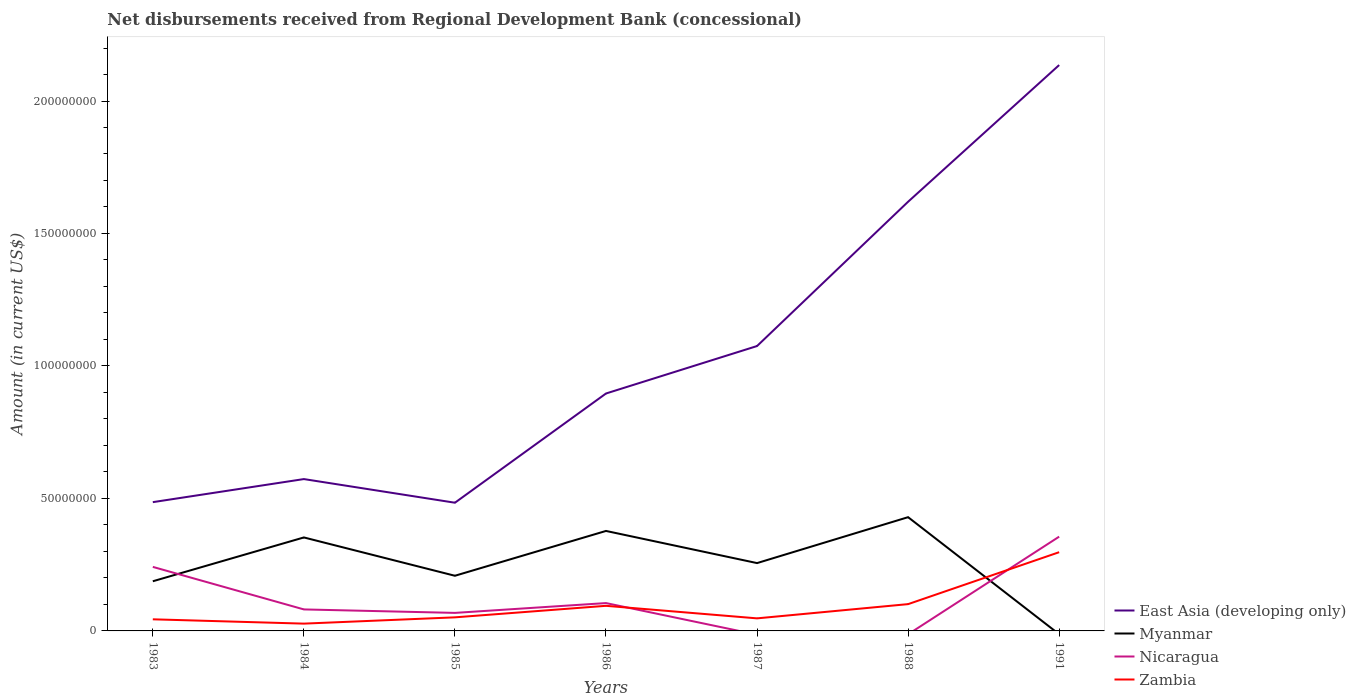How many different coloured lines are there?
Offer a very short reply. 4. Across all years, what is the maximum amount of disbursements received from Regional Development Bank in East Asia (developing only)?
Make the answer very short. 4.84e+07. What is the total amount of disbursements received from Regional Development Bank in Myanmar in the graph?
Provide a short and direct response. -1.65e+07. What is the difference between the highest and the second highest amount of disbursements received from Regional Development Bank in Zambia?
Offer a very short reply. 2.70e+07. Is the amount of disbursements received from Regional Development Bank in East Asia (developing only) strictly greater than the amount of disbursements received from Regional Development Bank in Myanmar over the years?
Your answer should be very brief. No. How many lines are there?
Provide a succinct answer. 4. How are the legend labels stacked?
Ensure brevity in your answer.  Vertical. What is the title of the graph?
Provide a succinct answer. Net disbursements received from Regional Development Bank (concessional). What is the label or title of the X-axis?
Offer a terse response. Years. What is the label or title of the Y-axis?
Your response must be concise. Amount (in current US$). What is the Amount (in current US$) in East Asia (developing only) in 1983?
Keep it short and to the point. 4.86e+07. What is the Amount (in current US$) in Myanmar in 1983?
Your response must be concise. 1.87e+07. What is the Amount (in current US$) of Nicaragua in 1983?
Offer a terse response. 2.42e+07. What is the Amount (in current US$) of Zambia in 1983?
Provide a succinct answer. 4.38e+06. What is the Amount (in current US$) in East Asia (developing only) in 1984?
Your answer should be very brief. 5.73e+07. What is the Amount (in current US$) in Myanmar in 1984?
Your answer should be compact. 3.53e+07. What is the Amount (in current US$) of Nicaragua in 1984?
Give a very brief answer. 8.12e+06. What is the Amount (in current US$) of Zambia in 1984?
Make the answer very short. 2.76e+06. What is the Amount (in current US$) in East Asia (developing only) in 1985?
Provide a short and direct response. 4.84e+07. What is the Amount (in current US$) of Myanmar in 1985?
Your answer should be compact. 2.08e+07. What is the Amount (in current US$) in Nicaragua in 1985?
Keep it short and to the point. 6.80e+06. What is the Amount (in current US$) of Zambia in 1985?
Ensure brevity in your answer.  5.12e+06. What is the Amount (in current US$) of East Asia (developing only) in 1986?
Ensure brevity in your answer.  8.96e+07. What is the Amount (in current US$) of Myanmar in 1986?
Provide a succinct answer. 3.77e+07. What is the Amount (in current US$) in Nicaragua in 1986?
Make the answer very short. 1.05e+07. What is the Amount (in current US$) of Zambia in 1986?
Provide a short and direct response. 9.48e+06. What is the Amount (in current US$) of East Asia (developing only) in 1987?
Your answer should be very brief. 1.08e+08. What is the Amount (in current US$) in Myanmar in 1987?
Make the answer very short. 2.56e+07. What is the Amount (in current US$) of Nicaragua in 1987?
Provide a succinct answer. 0. What is the Amount (in current US$) of Zambia in 1987?
Your answer should be very brief. 4.74e+06. What is the Amount (in current US$) of East Asia (developing only) in 1988?
Offer a terse response. 1.62e+08. What is the Amount (in current US$) of Myanmar in 1988?
Offer a terse response. 4.29e+07. What is the Amount (in current US$) of Zambia in 1988?
Provide a short and direct response. 1.01e+07. What is the Amount (in current US$) of East Asia (developing only) in 1991?
Ensure brevity in your answer.  2.14e+08. What is the Amount (in current US$) of Myanmar in 1991?
Your response must be concise. 0. What is the Amount (in current US$) of Nicaragua in 1991?
Your response must be concise. 3.56e+07. What is the Amount (in current US$) in Zambia in 1991?
Your response must be concise. 2.97e+07. Across all years, what is the maximum Amount (in current US$) in East Asia (developing only)?
Give a very brief answer. 2.14e+08. Across all years, what is the maximum Amount (in current US$) in Myanmar?
Make the answer very short. 4.29e+07. Across all years, what is the maximum Amount (in current US$) in Nicaragua?
Provide a short and direct response. 3.56e+07. Across all years, what is the maximum Amount (in current US$) of Zambia?
Offer a terse response. 2.97e+07. Across all years, what is the minimum Amount (in current US$) of East Asia (developing only)?
Your answer should be very brief. 4.84e+07. Across all years, what is the minimum Amount (in current US$) of Myanmar?
Give a very brief answer. 0. Across all years, what is the minimum Amount (in current US$) in Zambia?
Offer a very short reply. 2.76e+06. What is the total Amount (in current US$) in East Asia (developing only) in the graph?
Offer a very short reply. 7.27e+08. What is the total Amount (in current US$) of Myanmar in the graph?
Offer a terse response. 1.81e+08. What is the total Amount (in current US$) in Nicaragua in the graph?
Keep it short and to the point. 8.52e+07. What is the total Amount (in current US$) of Zambia in the graph?
Give a very brief answer. 6.63e+07. What is the difference between the Amount (in current US$) in East Asia (developing only) in 1983 and that in 1984?
Give a very brief answer. -8.71e+06. What is the difference between the Amount (in current US$) in Myanmar in 1983 and that in 1984?
Your answer should be very brief. -1.65e+07. What is the difference between the Amount (in current US$) in Nicaragua in 1983 and that in 1984?
Offer a terse response. 1.61e+07. What is the difference between the Amount (in current US$) of Zambia in 1983 and that in 1984?
Your answer should be very brief. 1.62e+06. What is the difference between the Amount (in current US$) in East Asia (developing only) in 1983 and that in 1985?
Offer a very short reply. 2.18e+05. What is the difference between the Amount (in current US$) in Myanmar in 1983 and that in 1985?
Your answer should be very brief. -2.08e+06. What is the difference between the Amount (in current US$) of Nicaragua in 1983 and that in 1985?
Make the answer very short. 1.74e+07. What is the difference between the Amount (in current US$) in Zambia in 1983 and that in 1985?
Offer a terse response. -7.45e+05. What is the difference between the Amount (in current US$) of East Asia (developing only) in 1983 and that in 1986?
Your answer should be compact. -4.10e+07. What is the difference between the Amount (in current US$) in Myanmar in 1983 and that in 1986?
Give a very brief answer. -1.90e+07. What is the difference between the Amount (in current US$) of Nicaragua in 1983 and that in 1986?
Provide a succinct answer. 1.37e+07. What is the difference between the Amount (in current US$) of Zambia in 1983 and that in 1986?
Provide a succinct answer. -5.10e+06. What is the difference between the Amount (in current US$) in East Asia (developing only) in 1983 and that in 1987?
Your response must be concise. -5.89e+07. What is the difference between the Amount (in current US$) in Myanmar in 1983 and that in 1987?
Provide a succinct answer. -6.86e+06. What is the difference between the Amount (in current US$) of Zambia in 1983 and that in 1987?
Offer a very short reply. -3.61e+05. What is the difference between the Amount (in current US$) of East Asia (developing only) in 1983 and that in 1988?
Offer a terse response. -1.13e+08. What is the difference between the Amount (in current US$) of Myanmar in 1983 and that in 1988?
Offer a terse response. -2.42e+07. What is the difference between the Amount (in current US$) of Zambia in 1983 and that in 1988?
Keep it short and to the point. -5.73e+06. What is the difference between the Amount (in current US$) of East Asia (developing only) in 1983 and that in 1991?
Provide a short and direct response. -1.65e+08. What is the difference between the Amount (in current US$) of Nicaragua in 1983 and that in 1991?
Your answer should be very brief. -1.14e+07. What is the difference between the Amount (in current US$) in Zambia in 1983 and that in 1991?
Give a very brief answer. -2.53e+07. What is the difference between the Amount (in current US$) in East Asia (developing only) in 1984 and that in 1985?
Offer a terse response. 8.92e+06. What is the difference between the Amount (in current US$) in Myanmar in 1984 and that in 1985?
Give a very brief answer. 1.45e+07. What is the difference between the Amount (in current US$) in Nicaragua in 1984 and that in 1985?
Provide a succinct answer. 1.31e+06. What is the difference between the Amount (in current US$) of Zambia in 1984 and that in 1985?
Ensure brevity in your answer.  -2.37e+06. What is the difference between the Amount (in current US$) in East Asia (developing only) in 1984 and that in 1986?
Provide a short and direct response. -3.23e+07. What is the difference between the Amount (in current US$) of Myanmar in 1984 and that in 1986?
Keep it short and to the point. -2.45e+06. What is the difference between the Amount (in current US$) of Nicaragua in 1984 and that in 1986?
Provide a short and direct response. -2.39e+06. What is the difference between the Amount (in current US$) of Zambia in 1984 and that in 1986?
Provide a succinct answer. -6.72e+06. What is the difference between the Amount (in current US$) of East Asia (developing only) in 1984 and that in 1987?
Give a very brief answer. -5.02e+07. What is the difference between the Amount (in current US$) of Myanmar in 1984 and that in 1987?
Your answer should be very brief. 9.68e+06. What is the difference between the Amount (in current US$) in Zambia in 1984 and that in 1987?
Provide a succinct answer. -1.98e+06. What is the difference between the Amount (in current US$) in East Asia (developing only) in 1984 and that in 1988?
Provide a short and direct response. -1.05e+08. What is the difference between the Amount (in current US$) of Myanmar in 1984 and that in 1988?
Your response must be concise. -7.65e+06. What is the difference between the Amount (in current US$) of Zambia in 1984 and that in 1988?
Keep it short and to the point. -7.36e+06. What is the difference between the Amount (in current US$) in East Asia (developing only) in 1984 and that in 1991?
Offer a very short reply. -1.56e+08. What is the difference between the Amount (in current US$) in Nicaragua in 1984 and that in 1991?
Provide a succinct answer. -2.75e+07. What is the difference between the Amount (in current US$) in Zambia in 1984 and that in 1991?
Provide a succinct answer. -2.70e+07. What is the difference between the Amount (in current US$) of East Asia (developing only) in 1985 and that in 1986?
Offer a very short reply. -4.12e+07. What is the difference between the Amount (in current US$) in Myanmar in 1985 and that in 1986?
Make the answer very short. -1.69e+07. What is the difference between the Amount (in current US$) of Nicaragua in 1985 and that in 1986?
Your answer should be compact. -3.71e+06. What is the difference between the Amount (in current US$) of Zambia in 1985 and that in 1986?
Provide a succinct answer. -4.35e+06. What is the difference between the Amount (in current US$) of East Asia (developing only) in 1985 and that in 1987?
Make the answer very short. -5.91e+07. What is the difference between the Amount (in current US$) of Myanmar in 1985 and that in 1987?
Your response must be concise. -4.78e+06. What is the difference between the Amount (in current US$) in Zambia in 1985 and that in 1987?
Make the answer very short. 3.84e+05. What is the difference between the Amount (in current US$) of East Asia (developing only) in 1985 and that in 1988?
Offer a very short reply. -1.14e+08. What is the difference between the Amount (in current US$) of Myanmar in 1985 and that in 1988?
Make the answer very short. -2.21e+07. What is the difference between the Amount (in current US$) in Zambia in 1985 and that in 1988?
Make the answer very short. -4.99e+06. What is the difference between the Amount (in current US$) in East Asia (developing only) in 1985 and that in 1991?
Offer a very short reply. -1.65e+08. What is the difference between the Amount (in current US$) of Nicaragua in 1985 and that in 1991?
Your answer should be compact. -2.88e+07. What is the difference between the Amount (in current US$) in Zambia in 1985 and that in 1991?
Provide a short and direct response. -2.46e+07. What is the difference between the Amount (in current US$) of East Asia (developing only) in 1986 and that in 1987?
Offer a very short reply. -1.79e+07. What is the difference between the Amount (in current US$) in Myanmar in 1986 and that in 1987?
Make the answer very short. 1.21e+07. What is the difference between the Amount (in current US$) in Zambia in 1986 and that in 1987?
Give a very brief answer. 4.74e+06. What is the difference between the Amount (in current US$) of East Asia (developing only) in 1986 and that in 1988?
Your answer should be compact. -7.24e+07. What is the difference between the Amount (in current US$) in Myanmar in 1986 and that in 1988?
Provide a short and direct response. -5.20e+06. What is the difference between the Amount (in current US$) in Zambia in 1986 and that in 1988?
Your response must be concise. -6.37e+05. What is the difference between the Amount (in current US$) of East Asia (developing only) in 1986 and that in 1991?
Ensure brevity in your answer.  -1.24e+08. What is the difference between the Amount (in current US$) of Nicaragua in 1986 and that in 1991?
Provide a short and direct response. -2.51e+07. What is the difference between the Amount (in current US$) in Zambia in 1986 and that in 1991?
Offer a terse response. -2.02e+07. What is the difference between the Amount (in current US$) in East Asia (developing only) in 1987 and that in 1988?
Offer a very short reply. -5.45e+07. What is the difference between the Amount (in current US$) of Myanmar in 1987 and that in 1988?
Make the answer very short. -1.73e+07. What is the difference between the Amount (in current US$) of Zambia in 1987 and that in 1988?
Offer a very short reply. -5.37e+06. What is the difference between the Amount (in current US$) in East Asia (developing only) in 1987 and that in 1991?
Make the answer very short. -1.06e+08. What is the difference between the Amount (in current US$) of Zambia in 1987 and that in 1991?
Your answer should be very brief. -2.50e+07. What is the difference between the Amount (in current US$) of East Asia (developing only) in 1988 and that in 1991?
Your answer should be compact. -5.16e+07. What is the difference between the Amount (in current US$) in Zambia in 1988 and that in 1991?
Keep it short and to the point. -1.96e+07. What is the difference between the Amount (in current US$) of East Asia (developing only) in 1983 and the Amount (in current US$) of Myanmar in 1984?
Your response must be concise. 1.33e+07. What is the difference between the Amount (in current US$) of East Asia (developing only) in 1983 and the Amount (in current US$) of Nicaragua in 1984?
Your response must be concise. 4.05e+07. What is the difference between the Amount (in current US$) in East Asia (developing only) in 1983 and the Amount (in current US$) in Zambia in 1984?
Make the answer very short. 4.58e+07. What is the difference between the Amount (in current US$) in Myanmar in 1983 and the Amount (in current US$) in Nicaragua in 1984?
Give a very brief answer. 1.06e+07. What is the difference between the Amount (in current US$) in Myanmar in 1983 and the Amount (in current US$) in Zambia in 1984?
Provide a succinct answer. 1.60e+07. What is the difference between the Amount (in current US$) in Nicaragua in 1983 and the Amount (in current US$) in Zambia in 1984?
Make the answer very short. 2.14e+07. What is the difference between the Amount (in current US$) in East Asia (developing only) in 1983 and the Amount (in current US$) in Myanmar in 1985?
Provide a succinct answer. 2.78e+07. What is the difference between the Amount (in current US$) of East Asia (developing only) in 1983 and the Amount (in current US$) of Nicaragua in 1985?
Give a very brief answer. 4.18e+07. What is the difference between the Amount (in current US$) of East Asia (developing only) in 1983 and the Amount (in current US$) of Zambia in 1985?
Your answer should be compact. 4.35e+07. What is the difference between the Amount (in current US$) of Myanmar in 1983 and the Amount (in current US$) of Nicaragua in 1985?
Keep it short and to the point. 1.19e+07. What is the difference between the Amount (in current US$) in Myanmar in 1983 and the Amount (in current US$) in Zambia in 1985?
Your response must be concise. 1.36e+07. What is the difference between the Amount (in current US$) of Nicaragua in 1983 and the Amount (in current US$) of Zambia in 1985?
Provide a succinct answer. 1.90e+07. What is the difference between the Amount (in current US$) in East Asia (developing only) in 1983 and the Amount (in current US$) in Myanmar in 1986?
Your response must be concise. 1.09e+07. What is the difference between the Amount (in current US$) in East Asia (developing only) in 1983 and the Amount (in current US$) in Nicaragua in 1986?
Provide a succinct answer. 3.81e+07. What is the difference between the Amount (in current US$) of East Asia (developing only) in 1983 and the Amount (in current US$) of Zambia in 1986?
Provide a short and direct response. 3.91e+07. What is the difference between the Amount (in current US$) of Myanmar in 1983 and the Amount (in current US$) of Nicaragua in 1986?
Your answer should be compact. 8.23e+06. What is the difference between the Amount (in current US$) in Myanmar in 1983 and the Amount (in current US$) in Zambia in 1986?
Provide a short and direct response. 9.26e+06. What is the difference between the Amount (in current US$) in Nicaragua in 1983 and the Amount (in current US$) in Zambia in 1986?
Give a very brief answer. 1.47e+07. What is the difference between the Amount (in current US$) of East Asia (developing only) in 1983 and the Amount (in current US$) of Myanmar in 1987?
Make the answer very short. 2.30e+07. What is the difference between the Amount (in current US$) of East Asia (developing only) in 1983 and the Amount (in current US$) of Zambia in 1987?
Offer a terse response. 4.39e+07. What is the difference between the Amount (in current US$) in Myanmar in 1983 and the Amount (in current US$) in Zambia in 1987?
Offer a terse response. 1.40e+07. What is the difference between the Amount (in current US$) in Nicaragua in 1983 and the Amount (in current US$) in Zambia in 1987?
Offer a terse response. 1.94e+07. What is the difference between the Amount (in current US$) in East Asia (developing only) in 1983 and the Amount (in current US$) in Myanmar in 1988?
Your answer should be very brief. 5.67e+06. What is the difference between the Amount (in current US$) of East Asia (developing only) in 1983 and the Amount (in current US$) of Zambia in 1988?
Provide a short and direct response. 3.85e+07. What is the difference between the Amount (in current US$) of Myanmar in 1983 and the Amount (in current US$) of Zambia in 1988?
Your answer should be very brief. 8.63e+06. What is the difference between the Amount (in current US$) in Nicaragua in 1983 and the Amount (in current US$) in Zambia in 1988?
Offer a terse response. 1.41e+07. What is the difference between the Amount (in current US$) of East Asia (developing only) in 1983 and the Amount (in current US$) of Nicaragua in 1991?
Keep it short and to the point. 1.30e+07. What is the difference between the Amount (in current US$) in East Asia (developing only) in 1983 and the Amount (in current US$) in Zambia in 1991?
Ensure brevity in your answer.  1.89e+07. What is the difference between the Amount (in current US$) in Myanmar in 1983 and the Amount (in current US$) in Nicaragua in 1991?
Make the answer very short. -1.68e+07. What is the difference between the Amount (in current US$) of Myanmar in 1983 and the Amount (in current US$) of Zambia in 1991?
Offer a very short reply. -1.10e+07. What is the difference between the Amount (in current US$) of Nicaragua in 1983 and the Amount (in current US$) of Zambia in 1991?
Your answer should be compact. -5.54e+06. What is the difference between the Amount (in current US$) of East Asia (developing only) in 1984 and the Amount (in current US$) of Myanmar in 1985?
Your response must be concise. 3.65e+07. What is the difference between the Amount (in current US$) of East Asia (developing only) in 1984 and the Amount (in current US$) of Nicaragua in 1985?
Your response must be concise. 5.05e+07. What is the difference between the Amount (in current US$) of East Asia (developing only) in 1984 and the Amount (in current US$) of Zambia in 1985?
Your answer should be very brief. 5.22e+07. What is the difference between the Amount (in current US$) of Myanmar in 1984 and the Amount (in current US$) of Nicaragua in 1985?
Provide a short and direct response. 2.85e+07. What is the difference between the Amount (in current US$) in Myanmar in 1984 and the Amount (in current US$) in Zambia in 1985?
Your answer should be very brief. 3.02e+07. What is the difference between the Amount (in current US$) in Nicaragua in 1984 and the Amount (in current US$) in Zambia in 1985?
Make the answer very short. 2.99e+06. What is the difference between the Amount (in current US$) in East Asia (developing only) in 1984 and the Amount (in current US$) in Myanmar in 1986?
Keep it short and to the point. 1.96e+07. What is the difference between the Amount (in current US$) of East Asia (developing only) in 1984 and the Amount (in current US$) of Nicaragua in 1986?
Offer a terse response. 4.68e+07. What is the difference between the Amount (in current US$) of East Asia (developing only) in 1984 and the Amount (in current US$) of Zambia in 1986?
Your answer should be very brief. 4.78e+07. What is the difference between the Amount (in current US$) of Myanmar in 1984 and the Amount (in current US$) of Nicaragua in 1986?
Your response must be concise. 2.48e+07. What is the difference between the Amount (in current US$) in Myanmar in 1984 and the Amount (in current US$) in Zambia in 1986?
Make the answer very short. 2.58e+07. What is the difference between the Amount (in current US$) of Nicaragua in 1984 and the Amount (in current US$) of Zambia in 1986?
Offer a very short reply. -1.36e+06. What is the difference between the Amount (in current US$) in East Asia (developing only) in 1984 and the Amount (in current US$) in Myanmar in 1987?
Your answer should be very brief. 3.17e+07. What is the difference between the Amount (in current US$) in East Asia (developing only) in 1984 and the Amount (in current US$) in Zambia in 1987?
Your answer should be very brief. 5.26e+07. What is the difference between the Amount (in current US$) of Myanmar in 1984 and the Amount (in current US$) of Zambia in 1987?
Provide a succinct answer. 3.05e+07. What is the difference between the Amount (in current US$) in Nicaragua in 1984 and the Amount (in current US$) in Zambia in 1987?
Provide a succinct answer. 3.38e+06. What is the difference between the Amount (in current US$) in East Asia (developing only) in 1984 and the Amount (in current US$) in Myanmar in 1988?
Offer a very short reply. 1.44e+07. What is the difference between the Amount (in current US$) of East Asia (developing only) in 1984 and the Amount (in current US$) of Zambia in 1988?
Offer a very short reply. 4.72e+07. What is the difference between the Amount (in current US$) of Myanmar in 1984 and the Amount (in current US$) of Zambia in 1988?
Give a very brief answer. 2.52e+07. What is the difference between the Amount (in current US$) in Nicaragua in 1984 and the Amount (in current US$) in Zambia in 1988?
Offer a terse response. -2.00e+06. What is the difference between the Amount (in current US$) in East Asia (developing only) in 1984 and the Amount (in current US$) in Nicaragua in 1991?
Provide a succinct answer. 2.17e+07. What is the difference between the Amount (in current US$) of East Asia (developing only) in 1984 and the Amount (in current US$) of Zambia in 1991?
Keep it short and to the point. 2.76e+07. What is the difference between the Amount (in current US$) in Myanmar in 1984 and the Amount (in current US$) in Nicaragua in 1991?
Give a very brief answer. -2.95e+05. What is the difference between the Amount (in current US$) of Myanmar in 1984 and the Amount (in current US$) of Zambia in 1991?
Your answer should be compact. 5.57e+06. What is the difference between the Amount (in current US$) in Nicaragua in 1984 and the Amount (in current US$) in Zambia in 1991?
Provide a short and direct response. -2.16e+07. What is the difference between the Amount (in current US$) in East Asia (developing only) in 1985 and the Amount (in current US$) in Myanmar in 1986?
Your response must be concise. 1.06e+07. What is the difference between the Amount (in current US$) in East Asia (developing only) in 1985 and the Amount (in current US$) in Nicaragua in 1986?
Provide a short and direct response. 3.79e+07. What is the difference between the Amount (in current US$) in East Asia (developing only) in 1985 and the Amount (in current US$) in Zambia in 1986?
Provide a short and direct response. 3.89e+07. What is the difference between the Amount (in current US$) in Myanmar in 1985 and the Amount (in current US$) in Nicaragua in 1986?
Your answer should be compact. 1.03e+07. What is the difference between the Amount (in current US$) in Myanmar in 1985 and the Amount (in current US$) in Zambia in 1986?
Give a very brief answer. 1.13e+07. What is the difference between the Amount (in current US$) of Nicaragua in 1985 and the Amount (in current US$) of Zambia in 1986?
Ensure brevity in your answer.  -2.67e+06. What is the difference between the Amount (in current US$) of East Asia (developing only) in 1985 and the Amount (in current US$) of Myanmar in 1987?
Make the answer very short. 2.28e+07. What is the difference between the Amount (in current US$) in East Asia (developing only) in 1985 and the Amount (in current US$) in Zambia in 1987?
Offer a very short reply. 4.36e+07. What is the difference between the Amount (in current US$) of Myanmar in 1985 and the Amount (in current US$) of Zambia in 1987?
Provide a succinct answer. 1.61e+07. What is the difference between the Amount (in current US$) of Nicaragua in 1985 and the Amount (in current US$) of Zambia in 1987?
Offer a very short reply. 2.06e+06. What is the difference between the Amount (in current US$) of East Asia (developing only) in 1985 and the Amount (in current US$) of Myanmar in 1988?
Offer a very short reply. 5.46e+06. What is the difference between the Amount (in current US$) of East Asia (developing only) in 1985 and the Amount (in current US$) of Zambia in 1988?
Your response must be concise. 3.83e+07. What is the difference between the Amount (in current US$) of Myanmar in 1985 and the Amount (in current US$) of Zambia in 1988?
Provide a short and direct response. 1.07e+07. What is the difference between the Amount (in current US$) of Nicaragua in 1985 and the Amount (in current US$) of Zambia in 1988?
Make the answer very short. -3.31e+06. What is the difference between the Amount (in current US$) of East Asia (developing only) in 1985 and the Amount (in current US$) of Nicaragua in 1991?
Your answer should be very brief. 1.28e+07. What is the difference between the Amount (in current US$) of East Asia (developing only) in 1985 and the Amount (in current US$) of Zambia in 1991?
Keep it short and to the point. 1.87e+07. What is the difference between the Amount (in current US$) of Myanmar in 1985 and the Amount (in current US$) of Nicaragua in 1991?
Keep it short and to the point. -1.48e+07. What is the difference between the Amount (in current US$) in Myanmar in 1985 and the Amount (in current US$) in Zambia in 1991?
Give a very brief answer. -8.89e+06. What is the difference between the Amount (in current US$) in Nicaragua in 1985 and the Amount (in current US$) in Zambia in 1991?
Make the answer very short. -2.29e+07. What is the difference between the Amount (in current US$) of East Asia (developing only) in 1986 and the Amount (in current US$) of Myanmar in 1987?
Keep it short and to the point. 6.40e+07. What is the difference between the Amount (in current US$) of East Asia (developing only) in 1986 and the Amount (in current US$) of Zambia in 1987?
Make the answer very short. 8.49e+07. What is the difference between the Amount (in current US$) in Myanmar in 1986 and the Amount (in current US$) in Zambia in 1987?
Make the answer very short. 3.30e+07. What is the difference between the Amount (in current US$) in Nicaragua in 1986 and the Amount (in current US$) in Zambia in 1987?
Offer a very short reply. 5.77e+06. What is the difference between the Amount (in current US$) of East Asia (developing only) in 1986 and the Amount (in current US$) of Myanmar in 1988?
Provide a short and direct response. 4.67e+07. What is the difference between the Amount (in current US$) in East Asia (developing only) in 1986 and the Amount (in current US$) in Zambia in 1988?
Offer a terse response. 7.95e+07. What is the difference between the Amount (in current US$) of Myanmar in 1986 and the Amount (in current US$) of Zambia in 1988?
Provide a short and direct response. 2.76e+07. What is the difference between the Amount (in current US$) of Nicaragua in 1986 and the Amount (in current US$) of Zambia in 1988?
Your response must be concise. 3.97e+05. What is the difference between the Amount (in current US$) of East Asia (developing only) in 1986 and the Amount (in current US$) of Nicaragua in 1991?
Make the answer very short. 5.40e+07. What is the difference between the Amount (in current US$) in East Asia (developing only) in 1986 and the Amount (in current US$) in Zambia in 1991?
Your answer should be very brief. 5.99e+07. What is the difference between the Amount (in current US$) of Myanmar in 1986 and the Amount (in current US$) of Nicaragua in 1991?
Make the answer very short. 2.16e+06. What is the difference between the Amount (in current US$) in Myanmar in 1986 and the Amount (in current US$) in Zambia in 1991?
Your answer should be very brief. 8.02e+06. What is the difference between the Amount (in current US$) of Nicaragua in 1986 and the Amount (in current US$) of Zambia in 1991?
Offer a terse response. -1.92e+07. What is the difference between the Amount (in current US$) in East Asia (developing only) in 1987 and the Amount (in current US$) in Myanmar in 1988?
Give a very brief answer. 6.46e+07. What is the difference between the Amount (in current US$) in East Asia (developing only) in 1987 and the Amount (in current US$) in Zambia in 1988?
Ensure brevity in your answer.  9.74e+07. What is the difference between the Amount (in current US$) in Myanmar in 1987 and the Amount (in current US$) in Zambia in 1988?
Provide a succinct answer. 1.55e+07. What is the difference between the Amount (in current US$) of East Asia (developing only) in 1987 and the Amount (in current US$) of Nicaragua in 1991?
Give a very brief answer. 7.19e+07. What is the difference between the Amount (in current US$) of East Asia (developing only) in 1987 and the Amount (in current US$) of Zambia in 1991?
Provide a succinct answer. 7.78e+07. What is the difference between the Amount (in current US$) in Myanmar in 1987 and the Amount (in current US$) in Nicaragua in 1991?
Provide a short and direct response. -9.98e+06. What is the difference between the Amount (in current US$) of Myanmar in 1987 and the Amount (in current US$) of Zambia in 1991?
Provide a short and direct response. -4.11e+06. What is the difference between the Amount (in current US$) in East Asia (developing only) in 1988 and the Amount (in current US$) in Nicaragua in 1991?
Ensure brevity in your answer.  1.26e+08. What is the difference between the Amount (in current US$) in East Asia (developing only) in 1988 and the Amount (in current US$) in Zambia in 1991?
Provide a short and direct response. 1.32e+08. What is the difference between the Amount (in current US$) of Myanmar in 1988 and the Amount (in current US$) of Nicaragua in 1991?
Your answer should be very brief. 7.35e+06. What is the difference between the Amount (in current US$) of Myanmar in 1988 and the Amount (in current US$) of Zambia in 1991?
Make the answer very short. 1.32e+07. What is the average Amount (in current US$) in East Asia (developing only) per year?
Your answer should be very brief. 1.04e+08. What is the average Amount (in current US$) of Myanmar per year?
Provide a short and direct response. 2.59e+07. What is the average Amount (in current US$) in Nicaragua per year?
Give a very brief answer. 1.22e+07. What is the average Amount (in current US$) in Zambia per year?
Your response must be concise. 9.47e+06. In the year 1983, what is the difference between the Amount (in current US$) of East Asia (developing only) and Amount (in current US$) of Myanmar?
Ensure brevity in your answer.  2.99e+07. In the year 1983, what is the difference between the Amount (in current US$) in East Asia (developing only) and Amount (in current US$) in Nicaragua?
Your answer should be compact. 2.44e+07. In the year 1983, what is the difference between the Amount (in current US$) in East Asia (developing only) and Amount (in current US$) in Zambia?
Offer a terse response. 4.42e+07. In the year 1983, what is the difference between the Amount (in current US$) in Myanmar and Amount (in current US$) in Nicaragua?
Provide a short and direct response. -5.43e+06. In the year 1983, what is the difference between the Amount (in current US$) in Myanmar and Amount (in current US$) in Zambia?
Give a very brief answer. 1.44e+07. In the year 1983, what is the difference between the Amount (in current US$) in Nicaragua and Amount (in current US$) in Zambia?
Make the answer very short. 1.98e+07. In the year 1984, what is the difference between the Amount (in current US$) of East Asia (developing only) and Amount (in current US$) of Myanmar?
Ensure brevity in your answer.  2.20e+07. In the year 1984, what is the difference between the Amount (in current US$) of East Asia (developing only) and Amount (in current US$) of Nicaragua?
Offer a terse response. 4.92e+07. In the year 1984, what is the difference between the Amount (in current US$) of East Asia (developing only) and Amount (in current US$) of Zambia?
Your answer should be compact. 5.46e+07. In the year 1984, what is the difference between the Amount (in current US$) of Myanmar and Amount (in current US$) of Nicaragua?
Keep it short and to the point. 2.72e+07. In the year 1984, what is the difference between the Amount (in current US$) in Myanmar and Amount (in current US$) in Zambia?
Provide a short and direct response. 3.25e+07. In the year 1984, what is the difference between the Amount (in current US$) in Nicaragua and Amount (in current US$) in Zambia?
Your answer should be very brief. 5.36e+06. In the year 1985, what is the difference between the Amount (in current US$) in East Asia (developing only) and Amount (in current US$) in Myanmar?
Provide a succinct answer. 2.76e+07. In the year 1985, what is the difference between the Amount (in current US$) in East Asia (developing only) and Amount (in current US$) in Nicaragua?
Make the answer very short. 4.16e+07. In the year 1985, what is the difference between the Amount (in current US$) in East Asia (developing only) and Amount (in current US$) in Zambia?
Keep it short and to the point. 4.33e+07. In the year 1985, what is the difference between the Amount (in current US$) in Myanmar and Amount (in current US$) in Nicaragua?
Give a very brief answer. 1.40e+07. In the year 1985, what is the difference between the Amount (in current US$) of Myanmar and Amount (in current US$) of Zambia?
Your answer should be very brief. 1.57e+07. In the year 1985, what is the difference between the Amount (in current US$) of Nicaragua and Amount (in current US$) of Zambia?
Offer a very short reply. 1.68e+06. In the year 1986, what is the difference between the Amount (in current US$) in East Asia (developing only) and Amount (in current US$) in Myanmar?
Offer a terse response. 5.19e+07. In the year 1986, what is the difference between the Amount (in current US$) of East Asia (developing only) and Amount (in current US$) of Nicaragua?
Your answer should be very brief. 7.91e+07. In the year 1986, what is the difference between the Amount (in current US$) in East Asia (developing only) and Amount (in current US$) in Zambia?
Offer a terse response. 8.01e+07. In the year 1986, what is the difference between the Amount (in current US$) of Myanmar and Amount (in current US$) of Nicaragua?
Offer a very short reply. 2.72e+07. In the year 1986, what is the difference between the Amount (in current US$) in Myanmar and Amount (in current US$) in Zambia?
Offer a very short reply. 2.83e+07. In the year 1986, what is the difference between the Amount (in current US$) of Nicaragua and Amount (in current US$) of Zambia?
Offer a terse response. 1.03e+06. In the year 1987, what is the difference between the Amount (in current US$) of East Asia (developing only) and Amount (in current US$) of Myanmar?
Keep it short and to the point. 8.19e+07. In the year 1987, what is the difference between the Amount (in current US$) of East Asia (developing only) and Amount (in current US$) of Zambia?
Offer a very short reply. 1.03e+08. In the year 1987, what is the difference between the Amount (in current US$) of Myanmar and Amount (in current US$) of Zambia?
Provide a succinct answer. 2.09e+07. In the year 1988, what is the difference between the Amount (in current US$) in East Asia (developing only) and Amount (in current US$) in Myanmar?
Provide a short and direct response. 1.19e+08. In the year 1988, what is the difference between the Amount (in current US$) of East Asia (developing only) and Amount (in current US$) of Zambia?
Provide a succinct answer. 1.52e+08. In the year 1988, what is the difference between the Amount (in current US$) of Myanmar and Amount (in current US$) of Zambia?
Make the answer very short. 3.28e+07. In the year 1991, what is the difference between the Amount (in current US$) of East Asia (developing only) and Amount (in current US$) of Nicaragua?
Your answer should be very brief. 1.78e+08. In the year 1991, what is the difference between the Amount (in current US$) in East Asia (developing only) and Amount (in current US$) in Zambia?
Give a very brief answer. 1.84e+08. In the year 1991, what is the difference between the Amount (in current US$) of Nicaragua and Amount (in current US$) of Zambia?
Offer a very short reply. 5.86e+06. What is the ratio of the Amount (in current US$) in East Asia (developing only) in 1983 to that in 1984?
Provide a short and direct response. 0.85. What is the ratio of the Amount (in current US$) of Myanmar in 1983 to that in 1984?
Make the answer very short. 0.53. What is the ratio of the Amount (in current US$) of Nicaragua in 1983 to that in 1984?
Offer a terse response. 2.98. What is the ratio of the Amount (in current US$) of Zambia in 1983 to that in 1984?
Your answer should be very brief. 1.59. What is the ratio of the Amount (in current US$) of Myanmar in 1983 to that in 1985?
Make the answer very short. 0.9. What is the ratio of the Amount (in current US$) in Nicaragua in 1983 to that in 1985?
Keep it short and to the point. 3.55. What is the ratio of the Amount (in current US$) of Zambia in 1983 to that in 1985?
Ensure brevity in your answer.  0.85. What is the ratio of the Amount (in current US$) of East Asia (developing only) in 1983 to that in 1986?
Provide a short and direct response. 0.54. What is the ratio of the Amount (in current US$) in Myanmar in 1983 to that in 1986?
Offer a very short reply. 0.5. What is the ratio of the Amount (in current US$) of Nicaragua in 1983 to that in 1986?
Ensure brevity in your answer.  2.3. What is the ratio of the Amount (in current US$) in Zambia in 1983 to that in 1986?
Your response must be concise. 0.46. What is the ratio of the Amount (in current US$) of East Asia (developing only) in 1983 to that in 1987?
Provide a succinct answer. 0.45. What is the ratio of the Amount (in current US$) in Myanmar in 1983 to that in 1987?
Ensure brevity in your answer.  0.73. What is the ratio of the Amount (in current US$) of Zambia in 1983 to that in 1987?
Make the answer very short. 0.92. What is the ratio of the Amount (in current US$) in East Asia (developing only) in 1983 to that in 1988?
Give a very brief answer. 0.3. What is the ratio of the Amount (in current US$) in Myanmar in 1983 to that in 1988?
Provide a succinct answer. 0.44. What is the ratio of the Amount (in current US$) in Zambia in 1983 to that in 1988?
Keep it short and to the point. 0.43. What is the ratio of the Amount (in current US$) of East Asia (developing only) in 1983 to that in 1991?
Your response must be concise. 0.23. What is the ratio of the Amount (in current US$) of Nicaragua in 1983 to that in 1991?
Keep it short and to the point. 0.68. What is the ratio of the Amount (in current US$) of Zambia in 1983 to that in 1991?
Your response must be concise. 0.15. What is the ratio of the Amount (in current US$) in East Asia (developing only) in 1984 to that in 1985?
Your answer should be compact. 1.18. What is the ratio of the Amount (in current US$) of Myanmar in 1984 to that in 1985?
Offer a very short reply. 1.69. What is the ratio of the Amount (in current US$) in Nicaragua in 1984 to that in 1985?
Provide a succinct answer. 1.19. What is the ratio of the Amount (in current US$) of Zambia in 1984 to that in 1985?
Offer a terse response. 0.54. What is the ratio of the Amount (in current US$) of East Asia (developing only) in 1984 to that in 1986?
Your answer should be very brief. 0.64. What is the ratio of the Amount (in current US$) of Myanmar in 1984 to that in 1986?
Offer a very short reply. 0.94. What is the ratio of the Amount (in current US$) in Nicaragua in 1984 to that in 1986?
Offer a very short reply. 0.77. What is the ratio of the Amount (in current US$) in Zambia in 1984 to that in 1986?
Offer a terse response. 0.29. What is the ratio of the Amount (in current US$) of East Asia (developing only) in 1984 to that in 1987?
Provide a succinct answer. 0.53. What is the ratio of the Amount (in current US$) of Myanmar in 1984 to that in 1987?
Your answer should be very brief. 1.38. What is the ratio of the Amount (in current US$) of Zambia in 1984 to that in 1987?
Ensure brevity in your answer.  0.58. What is the ratio of the Amount (in current US$) of East Asia (developing only) in 1984 to that in 1988?
Make the answer very short. 0.35. What is the ratio of the Amount (in current US$) of Myanmar in 1984 to that in 1988?
Offer a very short reply. 0.82. What is the ratio of the Amount (in current US$) of Zambia in 1984 to that in 1988?
Make the answer very short. 0.27. What is the ratio of the Amount (in current US$) of East Asia (developing only) in 1984 to that in 1991?
Your answer should be very brief. 0.27. What is the ratio of the Amount (in current US$) in Nicaragua in 1984 to that in 1991?
Your response must be concise. 0.23. What is the ratio of the Amount (in current US$) of Zambia in 1984 to that in 1991?
Make the answer very short. 0.09. What is the ratio of the Amount (in current US$) of East Asia (developing only) in 1985 to that in 1986?
Provide a succinct answer. 0.54. What is the ratio of the Amount (in current US$) in Myanmar in 1985 to that in 1986?
Offer a very short reply. 0.55. What is the ratio of the Amount (in current US$) of Nicaragua in 1985 to that in 1986?
Give a very brief answer. 0.65. What is the ratio of the Amount (in current US$) of Zambia in 1985 to that in 1986?
Give a very brief answer. 0.54. What is the ratio of the Amount (in current US$) in East Asia (developing only) in 1985 to that in 1987?
Provide a short and direct response. 0.45. What is the ratio of the Amount (in current US$) in Myanmar in 1985 to that in 1987?
Provide a succinct answer. 0.81. What is the ratio of the Amount (in current US$) of Zambia in 1985 to that in 1987?
Provide a succinct answer. 1.08. What is the ratio of the Amount (in current US$) in East Asia (developing only) in 1985 to that in 1988?
Your response must be concise. 0.3. What is the ratio of the Amount (in current US$) in Myanmar in 1985 to that in 1988?
Give a very brief answer. 0.48. What is the ratio of the Amount (in current US$) of Zambia in 1985 to that in 1988?
Your answer should be very brief. 0.51. What is the ratio of the Amount (in current US$) of East Asia (developing only) in 1985 to that in 1991?
Provide a short and direct response. 0.23. What is the ratio of the Amount (in current US$) of Nicaragua in 1985 to that in 1991?
Ensure brevity in your answer.  0.19. What is the ratio of the Amount (in current US$) in Zambia in 1985 to that in 1991?
Give a very brief answer. 0.17. What is the ratio of the Amount (in current US$) of East Asia (developing only) in 1986 to that in 1987?
Your answer should be very brief. 0.83. What is the ratio of the Amount (in current US$) in Myanmar in 1986 to that in 1987?
Provide a succinct answer. 1.47. What is the ratio of the Amount (in current US$) in Zambia in 1986 to that in 1987?
Keep it short and to the point. 2. What is the ratio of the Amount (in current US$) in East Asia (developing only) in 1986 to that in 1988?
Keep it short and to the point. 0.55. What is the ratio of the Amount (in current US$) of Myanmar in 1986 to that in 1988?
Make the answer very short. 0.88. What is the ratio of the Amount (in current US$) in Zambia in 1986 to that in 1988?
Your answer should be compact. 0.94. What is the ratio of the Amount (in current US$) of East Asia (developing only) in 1986 to that in 1991?
Keep it short and to the point. 0.42. What is the ratio of the Amount (in current US$) of Nicaragua in 1986 to that in 1991?
Offer a very short reply. 0.3. What is the ratio of the Amount (in current US$) of Zambia in 1986 to that in 1991?
Offer a very short reply. 0.32. What is the ratio of the Amount (in current US$) of East Asia (developing only) in 1987 to that in 1988?
Ensure brevity in your answer.  0.66. What is the ratio of the Amount (in current US$) in Myanmar in 1987 to that in 1988?
Your response must be concise. 0.6. What is the ratio of the Amount (in current US$) in Zambia in 1987 to that in 1988?
Offer a terse response. 0.47. What is the ratio of the Amount (in current US$) of East Asia (developing only) in 1987 to that in 1991?
Offer a very short reply. 0.5. What is the ratio of the Amount (in current US$) of Zambia in 1987 to that in 1991?
Keep it short and to the point. 0.16. What is the ratio of the Amount (in current US$) of East Asia (developing only) in 1988 to that in 1991?
Keep it short and to the point. 0.76. What is the ratio of the Amount (in current US$) of Zambia in 1988 to that in 1991?
Your response must be concise. 0.34. What is the difference between the highest and the second highest Amount (in current US$) in East Asia (developing only)?
Offer a very short reply. 5.16e+07. What is the difference between the highest and the second highest Amount (in current US$) of Myanmar?
Provide a short and direct response. 5.20e+06. What is the difference between the highest and the second highest Amount (in current US$) in Nicaragua?
Give a very brief answer. 1.14e+07. What is the difference between the highest and the second highest Amount (in current US$) in Zambia?
Keep it short and to the point. 1.96e+07. What is the difference between the highest and the lowest Amount (in current US$) in East Asia (developing only)?
Provide a succinct answer. 1.65e+08. What is the difference between the highest and the lowest Amount (in current US$) in Myanmar?
Make the answer very short. 4.29e+07. What is the difference between the highest and the lowest Amount (in current US$) in Nicaragua?
Provide a succinct answer. 3.56e+07. What is the difference between the highest and the lowest Amount (in current US$) in Zambia?
Offer a terse response. 2.70e+07. 